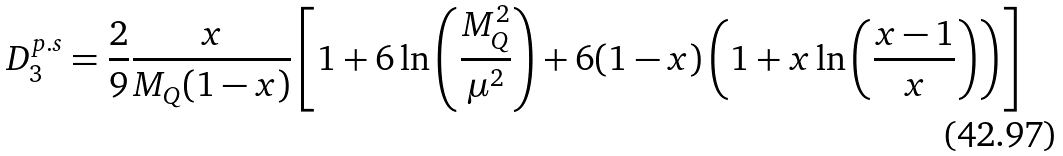Convert formula to latex. <formula><loc_0><loc_0><loc_500><loc_500>D _ { 3 } ^ { p . s } = \frac { 2 } { 9 } \frac { x } { M _ { Q } ( 1 - x ) } \left [ 1 + 6 \ln \left ( \frac { M _ { Q } ^ { 2 } } { \mu ^ { 2 } } \right ) + 6 ( 1 - x ) \left ( 1 + x \ln \left ( \frac { x - 1 } { x } \right ) \right ) \right ]</formula> 